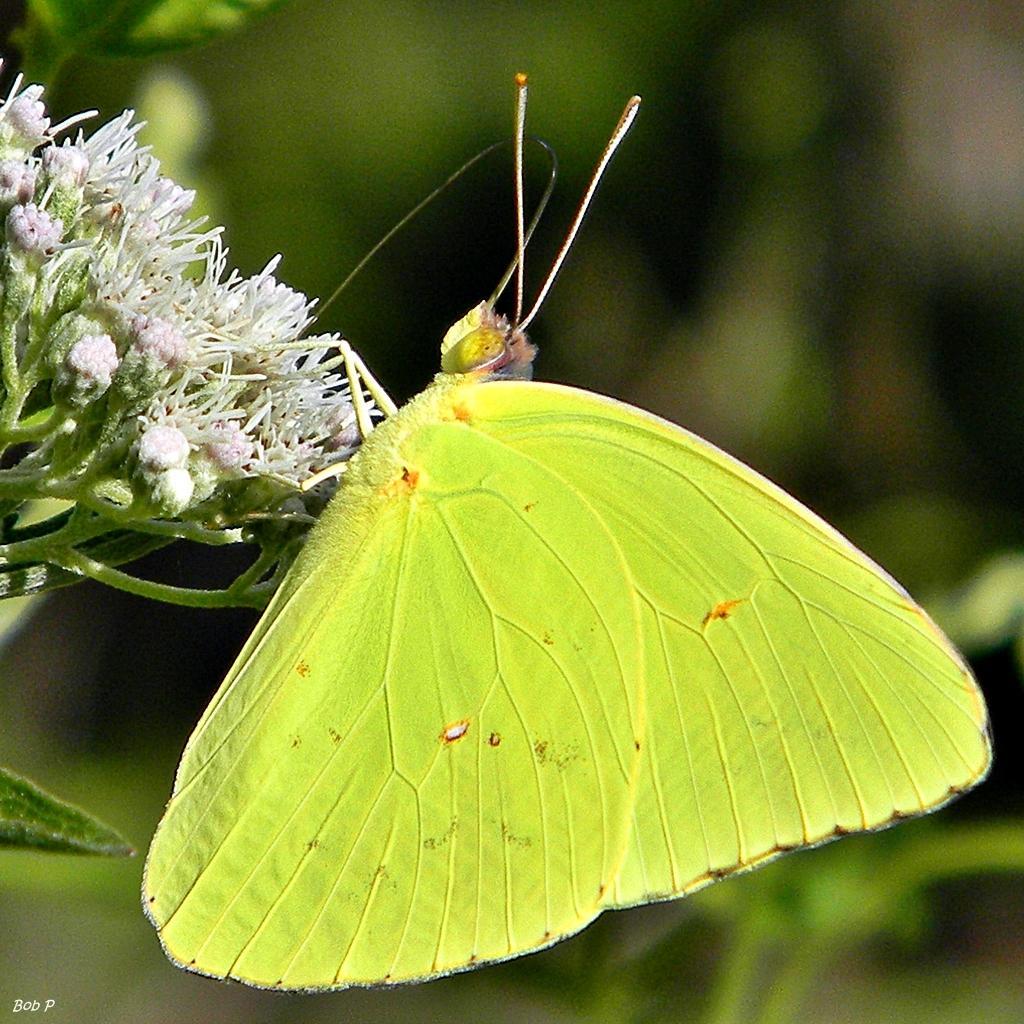Could you give a brief overview of what you see in this image? This picture shows a butterfly on the flower. The butterfly is green in color. 